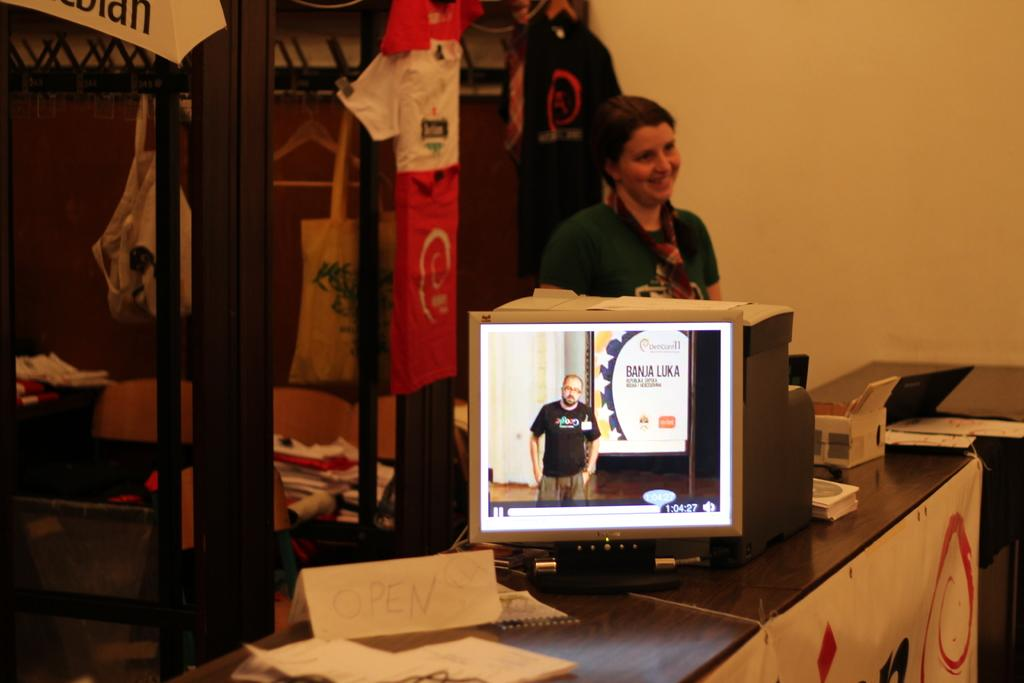Who is present in the image? There is a woman in the image. What is the woman doing in the image? The woman is smiling in the image. What electronic device is visible in the image? There is a monitor in the image. Is there any other image present in the image? Yes, there is a photo of a man in the image. What type of beef is being used to write on the monitor in the image? There is no beef present in the image, and the monitor is not being written on. What color is the ink used by the woman in the image? There is no ink or writing activity present in the image. 